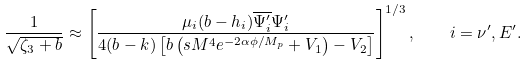Convert formula to latex. <formula><loc_0><loc_0><loc_500><loc_500>\frac { 1 } { \sqrt { \zeta _ { 3 } + b } } \approx \left [ \frac { \mu _ { i } ( b - h _ { i } ) \overline { \Psi ^ { \prime } _ { i } } \Psi ^ { \prime } _ { i } } { 4 ( b - k ) \left [ b \left ( s M ^ { 4 } e ^ { - 2 \alpha \phi / M _ { p } } + V _ { 1 } \right ) - V _ { 2 } \right ] } \right ] ^ { 1 / 3 } , \quad i = \nu ^ { \prime } , E ^ { \prime } .</formula> 